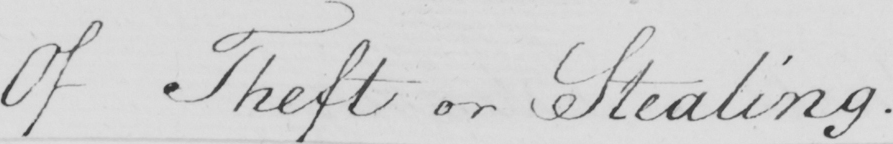Please provide the text content of this handwritten line. Of Theft or Stealing 